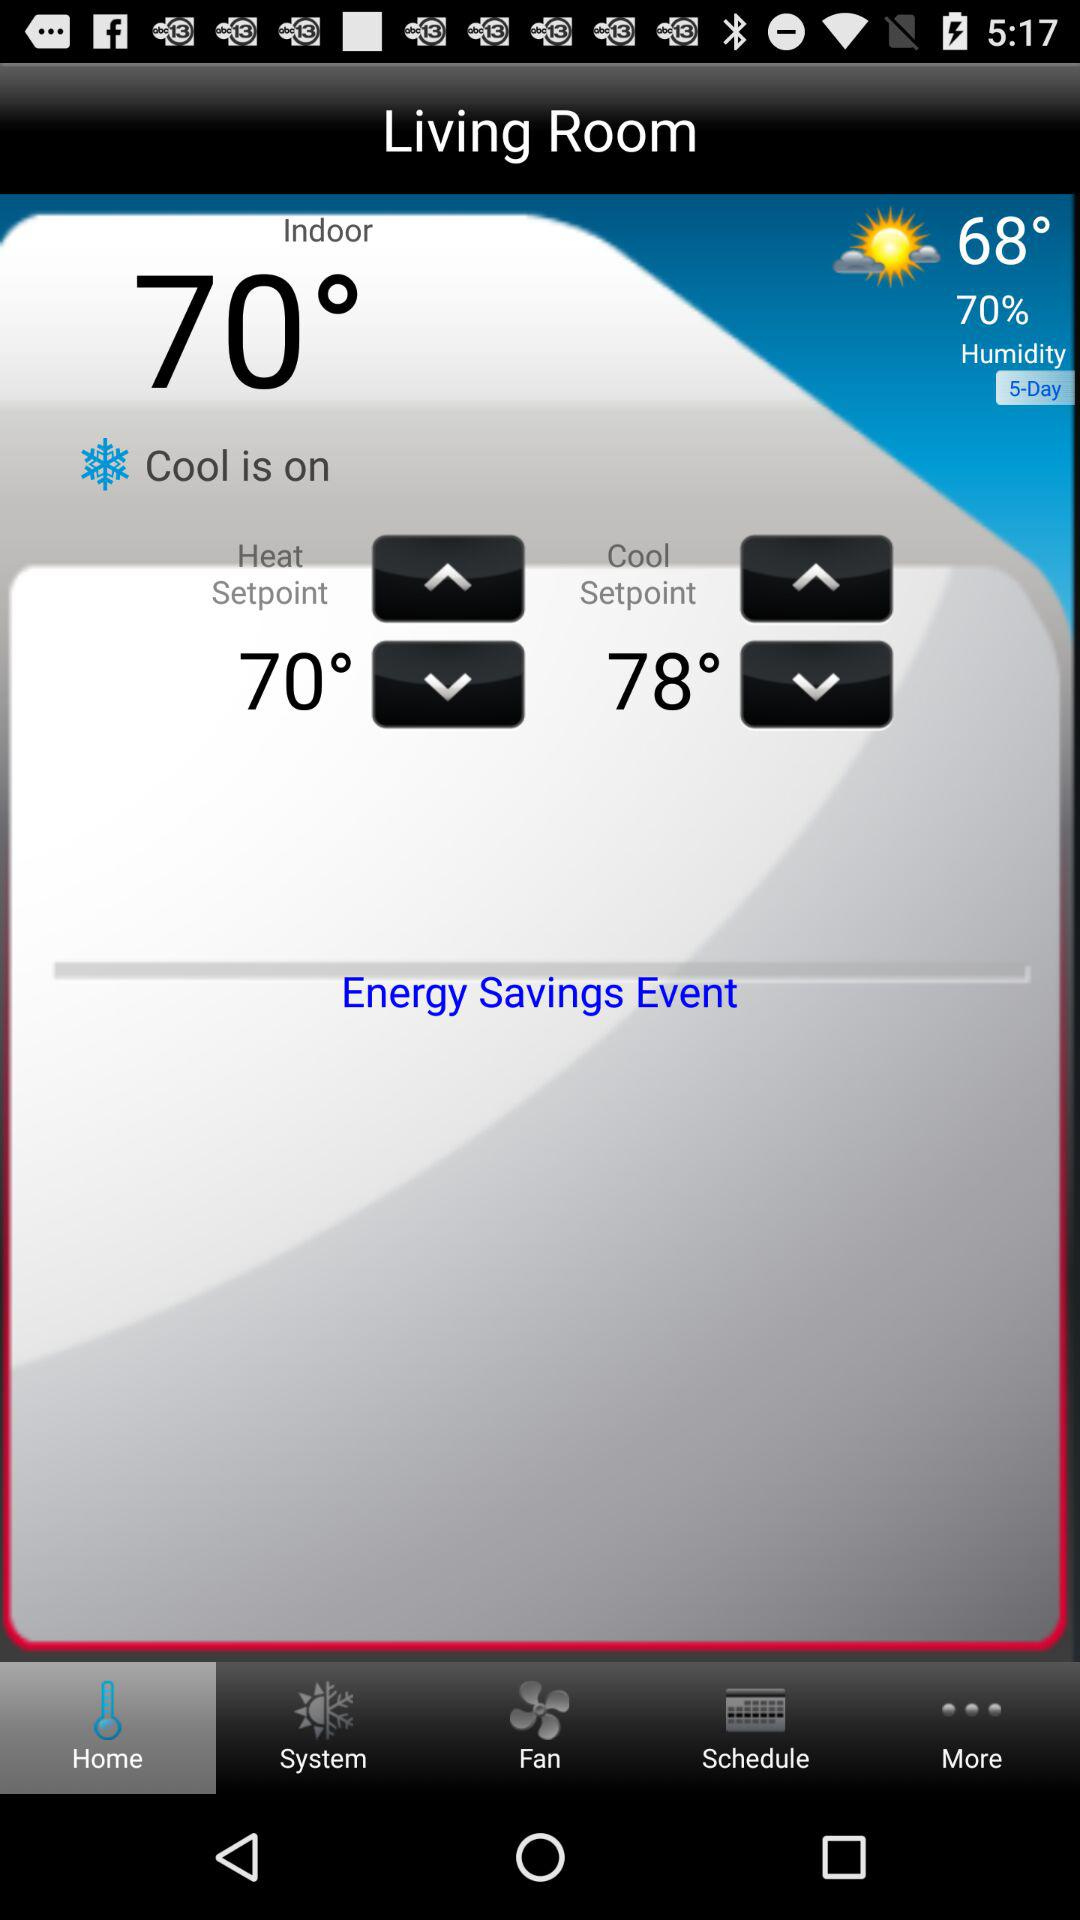What is the indoor temperature? The indoor temperature is 70°. 